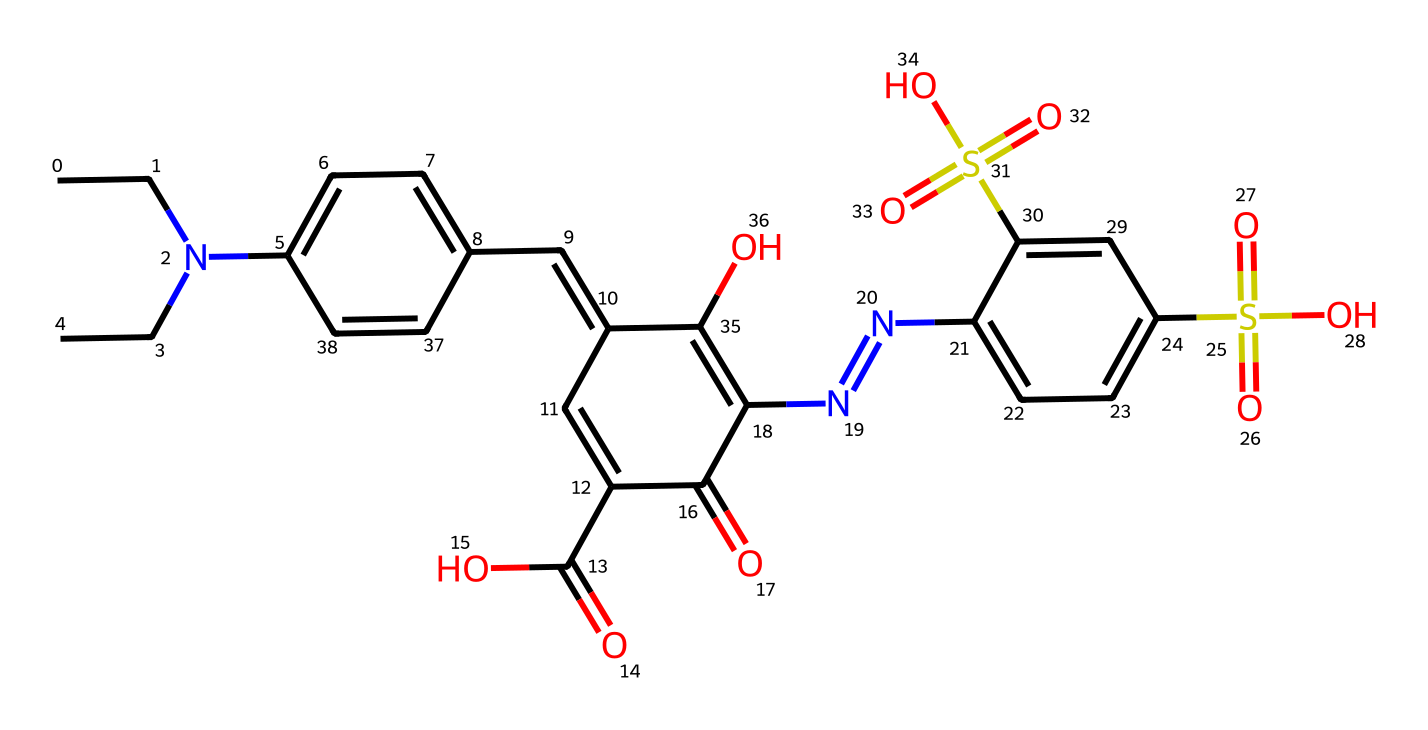What is the primary functional group present in this structure? The visible presence of -COOH groups indicates carboxylic acids, which are the primary functional groups observed in the chemical structure.
Answer: carboxylic acid How many rings are present in the chemical structure? Upon examining the structure, there are two distinct aromatic rings observed, indicating the presence of two rings in total.
Answer: two What is the total number of nitrogen atoms in the molecule? By counting the nitrogen atoms represented in the structure, there are two nitrogen atoms present, which can be confirmed by their locations in the SMILES representation.
Answer: two What type of chemical is this compound classified as? Given the structure's complex arrangement with multiple functional groups and color-related properties, this compound is classified as a synthetic dye.
Answer: synthetic dye What elements are found in this chemical structure? The chemical contains carbon, hydrogen, nitrogen, oxygen, and sulfur as key elements, evidenced by their respective symbols presented in the structure.
Answer: carbon, hydrogen, nitrogen, oxygen, sulfur What specific feature gives this compound its coloring properties? The presence of conjugated double bonds within the structure allows for the delocalization of electrons, which is a critical feature responsible for the absorption of specific wavelengths of light, giving its coloring properties.
Answer: conjugated double bonds 